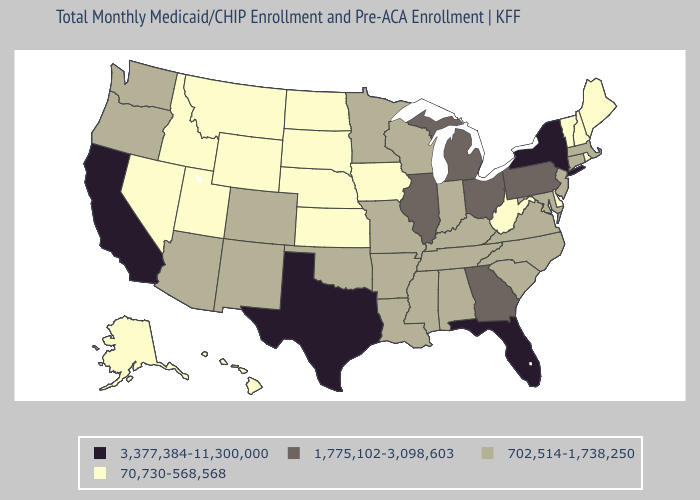Which states have the lowest value in the USA?
Give a very brief answer. Alaska, Delaware, Hawaii, Idaho, Iowa, Kansas, Maine, Montana, Nebraska, Nevada, New Hampshire, North Dakota, Rhode Island, South Dakota, Utah, Vermont, West Virginia, Wyoming. Does West Virginia have the highest value in the USA?
Give a very brief answer. No. What is the value of Illinois?
Write a very short answer. 1,775,102-3,098,603. Name the states that have a value in the range 3,377,384-11,300,000?
Answer briefly. California, Florida, New York, Texas. Name the states that have a value in the range 702,514-1,738,250?
Concise answer only. Alabama, Arizona, Arkansas, Colorado, Connecticut, Indiana, Kentucky, Louisiana, Maryland, Massachusetts, Minnesota, Mississippi, Missouri, New Jersey, New Mexico, North Carolina, Oklahoma, Oregon, South Carolina, Tennessee, Virginia, Washington, Wisconsin. What is the lowest value in the USA?
Give a very brief answer. 70,730-568,568. Name the states that have a value in the range 70,730-568,568?
Quick response, please. Alaska, Delaware, Hawaii, Idaho, Iowa, Kansas, Maine, Montana, Nebraska, Nevada, New Hampshire, North Dakota, Rhode Island, South Dakota, Utah, Vermont, West Virginia, Wyoming. What is the lowest value in the USA?
Concise answer only. 70,730-568,568. What is the value of California?
Keep it brief. 3,377,384-11,300,000. Among the states that border New Hampshire , does Massachusetts have the highest value?
Quick response, please. Yes. Name the states that have a value in the range 1,775,102-3,098,603?
Answer briefly. Georgia, Illinois, Michigan, Ohio, Pennsylvania. What is the lowest value in the South?
Give a very brief answer. 70,730-568,568. Name the states that have a value in the range 702,514-1,738,250?
Quick response, please. Alabama, Arizona, Arkansas, Colorado, Connecticut, Indiana, Kentucky, Louisiana, Maryland, Massachusetts, Minnesota, Mississippi, Missouri, New Jersey, New Mexico, North Carolina, Oklahoma, Oregon, South Carolina, Tennessee, Virginia, Washington, Wisconsin. Among the states that border Wyoming , which have the lowest value?
Answer briefly. Idaho, Montana, Nebraska, South Dakota, Utah. Does North Carolina have the same value as New Mexico?
Keep it brief. Yes. 